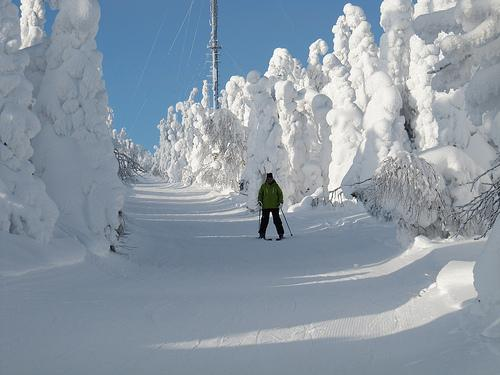What structures can be seen in the image? A power line pole and utility pole with ice can be seen, as well as tall, snow-covered trees and a snowy ski path. Describe any shadows or lighting visible in the image. Shadows from the snow-covered trees are cast on the ground, while sunlight streams through the branches, illuminating parts of the ski path and surrounding environment. What are some of the prominent objects visible in the image? Skier in a green coat, black ski poles, snow-covered trees, and a smooth snowy path. Who is the main subject, and what does the environment look like? The main subject is a skier in a green coat and black pants, surrounded by a snowy environment, thickly covered trees, and a smooth ski slope. How is the image compositionally balanced? The image achieves compositional balance through the placement of the skier as the main subject in the foreground, surrounded by an environment filled with snow-covered trees, smooth snowy path, and sunlight, creating visual interest and harmony. Name three objects in the image and their colors. Green coat on a skier, black ski pole, and white snow-packed trees. Analyze the interaction between the person and their environment. The skier is standing on a snowy path, using ski poles to navigate the terrain, while being surrounded by snow-covered trees, creating an enjoyable ski experience in a beautiful snow-covered landscape. What is the sentiment or mood conveyed by the image? The image conveys a serene and peaceful mood, as the skier enjoys the quiet beauty of the snow-covered environment, with sunlight streaming through the branches. Write a short narrative of the scene in the image. A skier, dressed in a green coat and black pants, is enjoying a skiing trip on a smooth, snowy path surrounded by tall, snow-covered trees. The sunlight streams through the branches, casting shadows on the ground, while the skier holds two black ski poles to maintain balance. Count the number of people in the image and describe what they are doing.  There is one person in the image, standing on skis and holding ski poles, while wearing a green coat and black pants. 